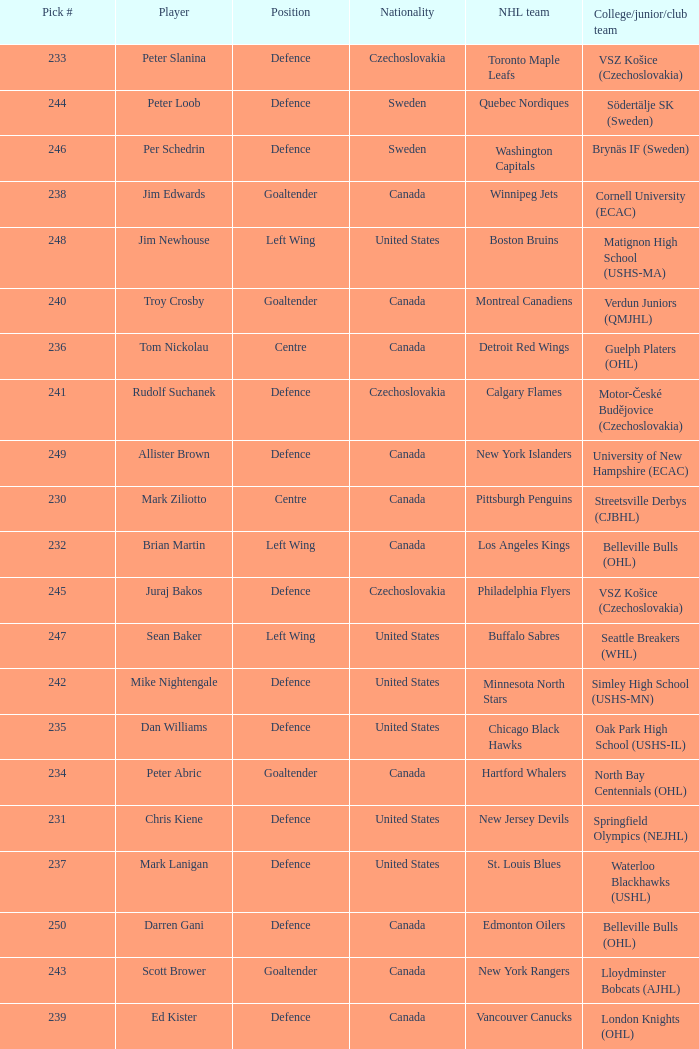Which draft number did the new jersey devils get? 231.0. 